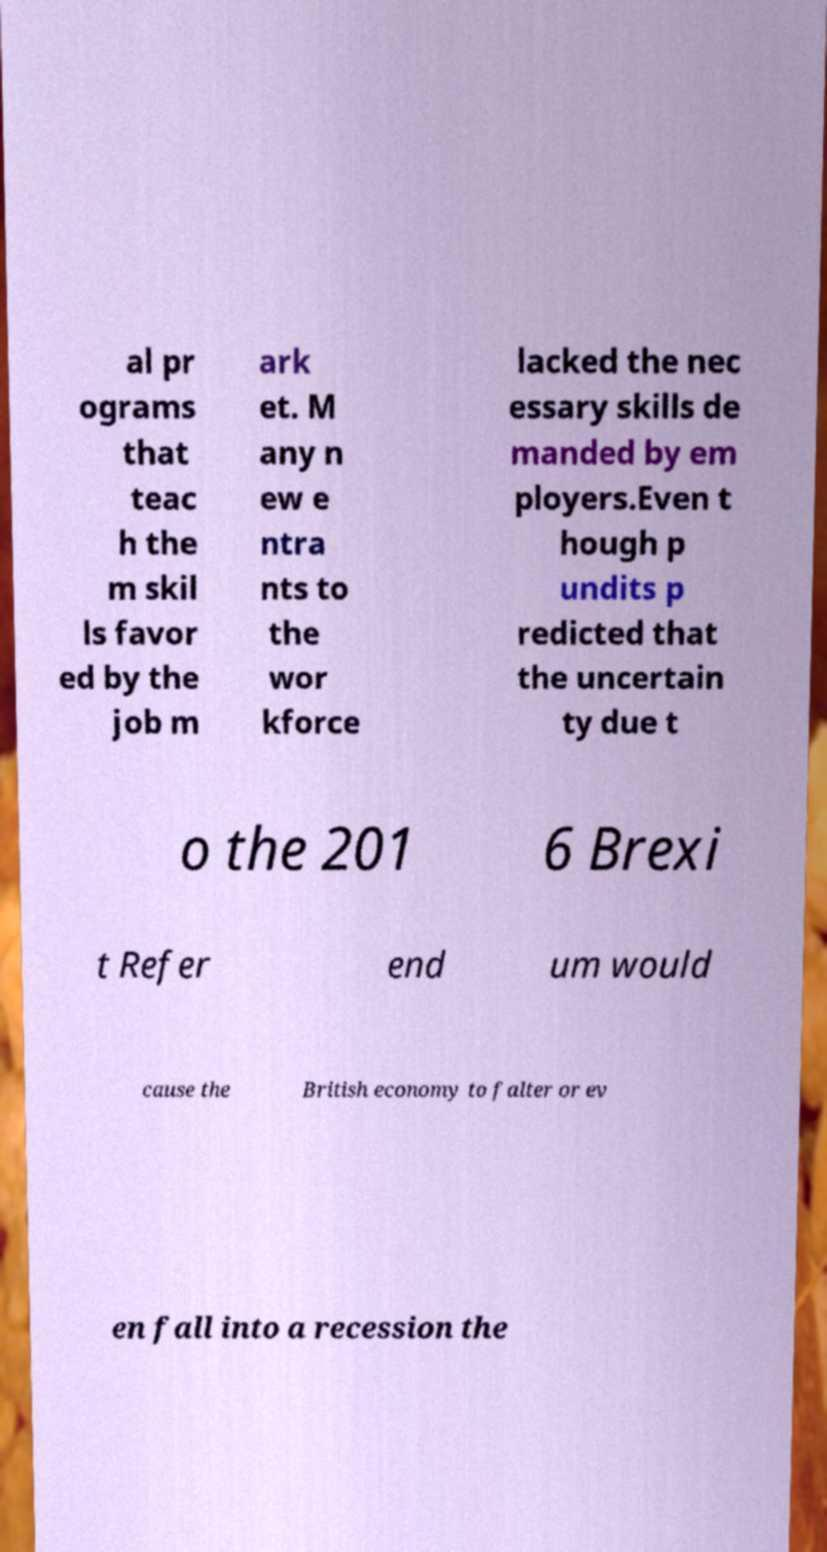Could you extract and type out the text from this image? al pr ograms that teac h the m skil ls favor ed by the job m ark et. M any n ew e ntra nts to the wor kforce lacked the nec essary skills de manded by em ployers.Even t hough p undits p redicted that the uncertain ty due t o the 201 6 Brexi t Refer end um would cause the British economy to falter or ev en fall into a recession the 